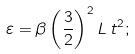<formula> <loc_0><loc_0><loc_500><loc_500>\varepsilon = \beta \left ( \frac { 3 } { 2 } \right ) ^ { 2 } L \, t ^ { 2 } ;</formula> 